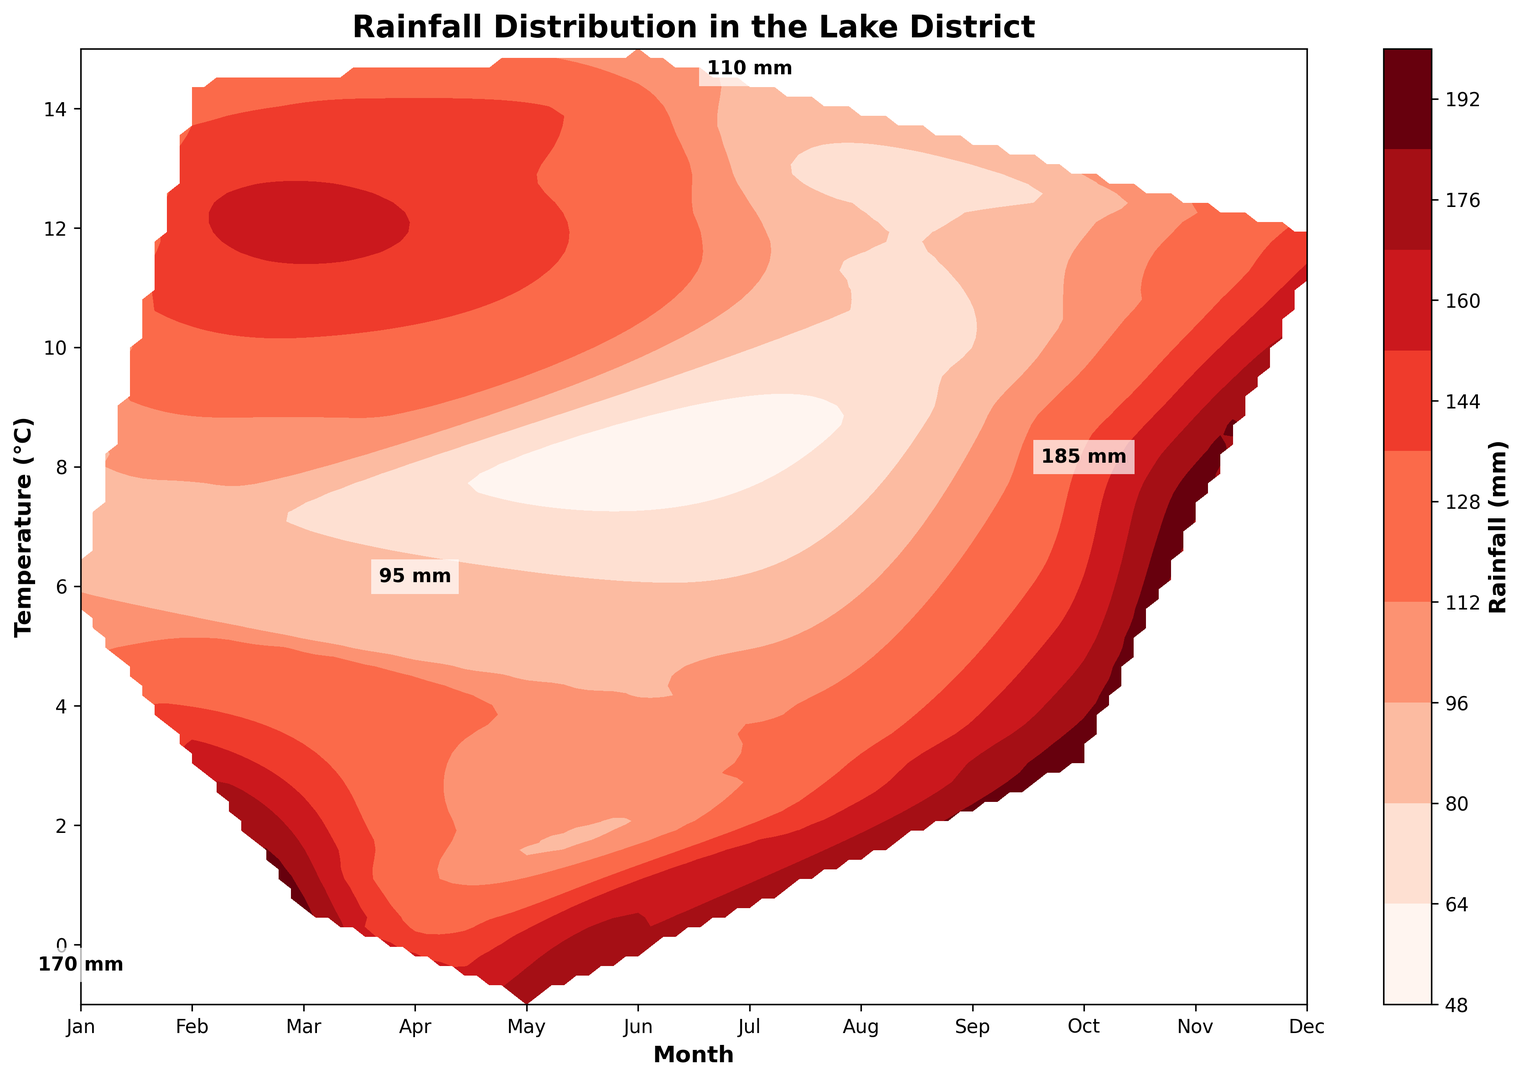What trends in rainfall can you observe across the months? Rainfall peaks can be observed in January and November-December, while the lower values are seen in April and May. This indicates a higher rainfall during the winter months and lower during the spring.
Answer: Higher in winter, lower in spring In which month does the rainfall exceed 190 mm? By observing the color intensity on the plot, October and November show values exceeding 190 mm, as indicated by the darkest shades of color and text annotations above 190 mm.
Answer: October, November Which month has the lowest average temperature and what is the rainfall during that month? The lowest average temperature is in January, with a temperature around -1°C and rainfall around 180 mm, indicated by its intense color shade and annotations on the plot.
Answer: January, about 180 mm How does rainfall change with temperature variations during the entire year? When observing the color gradient with temperature rise, lower temperatures (winter) correspond to higher rainfall maximum values, while higher temperatures (summer) correspond to relatively lower rainfall values.
Answer: Higher rainfall in winter, lower in summer Which months have similar rainfall patterns but different temperature levels? February and August have similar rainfall patterns around 130-140 mm mark, but very different temperatures of about 0.5°C in February and 13.5°C in August.
Answer: February, August Is there any month where the temperature is negative but rainfall is lower than 180 mm? According to the plot, January shows negative temperatures (around -1°C) with rainfall above 180 mm.
Answer: No Compare the rainfall in July with November. Which month receives more rainfall and by how much approximately? Observing the colors, the rainfall in November is indicated to be about 200 mm while in July it is around 110 mm. The difference can be calculated as approximately (200 - 110) mm.
Answer: November, around 90 mm Identify a pattern where the temperature is equal or greater than 10°C and rainfall is less than 100 mm, which months fit this pattern? From the plot, May (10°C and 80-90 mm) and June (12.5°C and 90-100 mm) fit this pattern.
Answer: May, June When does the Lake District experience the highest temperature and what is the approximate rainfall then? The highest temperature is observed in July with a temperature around 14.5°C and rainfall around 110 mm as indicated by the colors and annotations.
Answer: July, 110 mm Do there exist any months where the rainfall is exactly equal to 150 mm? If so, what are the corresponding temperatures during that month? The plot shows rainfall around 150 mm in March (about 3.5°C) and September (around 12°C).
Answer: March, September 